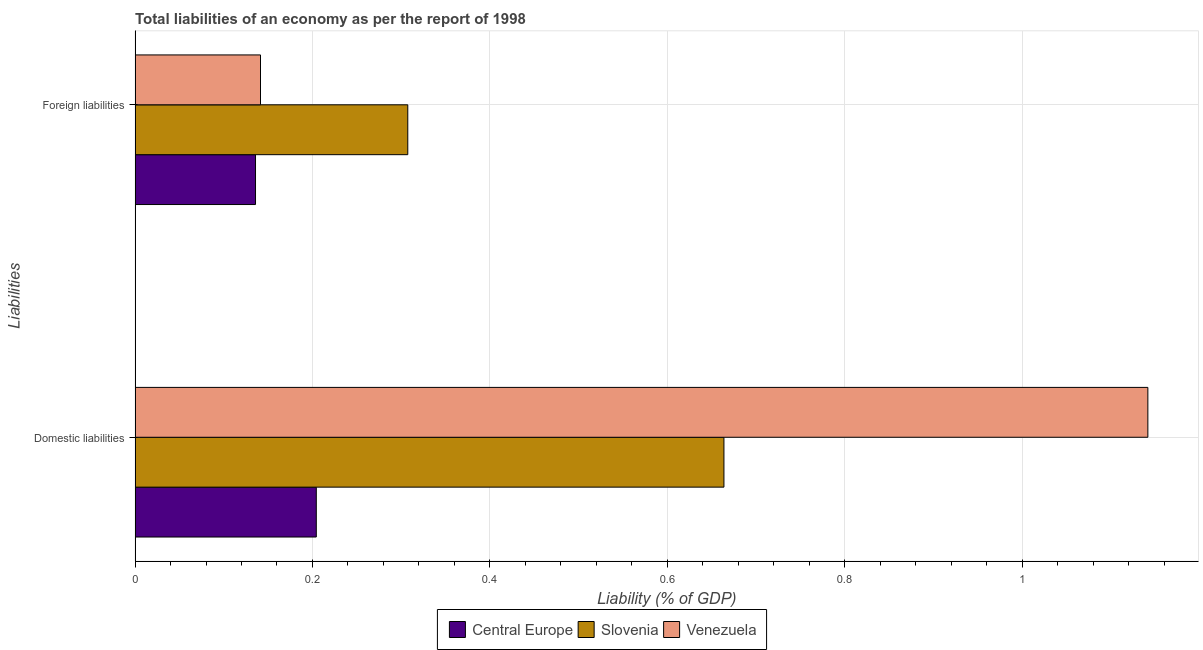How many groups of bars are there?
Give a very brief answer. 2. How many bars are there on the 1st tick from the bottom?
Give a very brief answer. 3. What is the label of the 1st group of bars from the top?
Make the answer very short. Foreign liabilities. What is the incurrence of foreign liabilities in Venezuela?
Your answer should be very brief. 0.14. Across all countries, what is the maximum incurrence of domestic liabilities?
Keep it short and to the point. 1.14. Across all countries, what is the minimum incurrence of foreign liabilities?
Provide a succinct answer. 0.14. In which country was the incurrence of domestic liabilities maximum?
Provide a short and direct response. Venezuela. In which country was the incurrence of domestic liabilities minimum?
Provide a succinct answer. Central Europe. What is the total incurrence of foreign liabilities in the graph?
Offer a very short reply. 0.58. What is the difference between the incurrence of foreign liabilities in Slovenia and that in Venezuela?
Your answer should be compact. 0.17. What is the difference between the incurrence of domestic liabilities in Venezuela and the incurrence of foreign liabilities in Slovenia?
Your answer should be very brief. 0.83. What is the average incurrence of foreign liabilities per country?
Offer a very short reply. 0.19. What is the difference between the incurrence of foreign liabilities and incurrence of domestic liabilities in Central Europe?
Your response must be concise. -0.07. In how many countries, is the incurrence of domestic liabilities greater than 0.36 %?
Make the answer very short. 2. What is the ratio of the incurrence of foreign liabilities in Central Europe to that in Slovenia?
Provide a short and direct response. 0.44. What does the 3rd bar from the top in Domestic liabilities represents?
Ensure brevity in your answer.  Central Europe. What does the 3rd bar from the bottom in Foreign liabilities represents?
Offer a terse response. Venezuela. Are the values on the major ticks of X-axis written in scientific E-notation?
Give a very brief answer. No. Does the graph contain any zero values?
Offer a terse response. No. How many legend labels are there?
Offer a terse response. 3. What is the title of the graph?
Provide a succinct answer. Total liabilities of an economy as per the report of 1998. What is the label or title of the X-axis?
Your answer should be very brief. Liability (% of GDP). What is the label or title of the Y-axis?
Provide a succinct answer. Liabilities. What is the Liability (% of GDP) in Central Europe in Domestic liabilities?
Give a very brief answer. 0.2. What is the Liability (% of GDP) in Slovenia in Domestic liabilities?
Your answer should be very brief. 0.66. What is the Liability (% of GDP) of Venezuela in Domestic liabilities?
Your answer should be compact. 1.14. What is the Liability (% of GDP) in Central Europe in Foreign liabilities?
Give a very brief answer. 0.14. What is the Liability (% of GDP) of Slovenia in Foreign liabilities?
Keep it short and to the point. 0.31. What is the Liability (% of GDP) in Venezuela in Foreign liabilities?
Your response must be concise. 0.14. Across all Liabilities, what is the maximum Liability (% of GDP) of Central Europe?
Provide a short and direct response. 0.2. Across all Liabilities, what is the maximum Liability (% of GDP) of Slovenia?
Provide a succinct answer. 0.66. Across all Liabilities, what is the maximum Liability (% of GDP) in Venezuela?
Make the answer very short. 1.14. Across all Liabilities, what is the minimum Liability (% of GDP) in Central Europe?
Give a very brief answer. 0.14. Across all Liabilities, what is the minimum Liability (% of GDP) in Slovenia?
Make the answer very short. 0.31. Across all Liabilities, what is the minimum Liability (% of GDP) of Venezuela?
Keep it short and to the point. 0.14. What is the total Liability (% of GDP) in Central Europe in the graph?
Offer a terse response. 0.34. What is the total Liability (% of GDP) of Slovenia in the graph?
Your answer should be very brief. 0.97. What is the total Liability (% of GDP) in Venezuela in the graph?
Your answer should be compact. 1.28. What is the difference between the Liability (% of GDP) of Central Europe in Domestic liabilities and that in Foreign liabilities?
Make the answer very short. 0.07. What is the difference between the Liability (% of GDP) in Slovenia in Domestic liabilities and that in Foreign liabilities?
Provide a succinct answer. 0.36. What is the difference between the Liability (% of GDP) in Central Europe in Domestic liabilities and the Liability (% of GDP) in Slovenia in Foreign liabilities?
Your answer should be very brief. -0.1. What is the difference between the Liability (% of GDP) of Central Europe in Domestic liabilities and the Liability (% of GDP) of Venezuela in Foreign liabilities?
Keep it short and to the point. 0.06. What is the difference between the Liability (% of GDP) in Slovenia in Domestic liabilities and the Liability (% of GDP) in Venezuela in Foreign liabilities?
Your response must be concise. 0.52. What is the average Liability (% of GDP) of Central Europe per Liabilities?
Provide a short and direct response. 0.17. What is the average Liability (% of GDP) of Slovenia per Liabilities?
Give a very brief answer. 0.49. What is the average Liability (% of GDP) in Venezuela per Liabilities?
Offer a terse response. 0.64. What is the difference between the Liability (% of GDP) of Central Europe and Liability (% of GDP) of Slovenia in Domestic liabilities?
Make the answer very short. -0.46. What is the difference between the Liability (% of GDP) of Central Europe and Liability (% of GDP) of Venezuela in Domestic liabilities?
Keep it short and to the point. -0.94. What is the difference between the Liability (% of GDP) in Slovenia and Liability (% of GDP) in Venezuela in Domestic liabilities?
Offer a very short reply. -0.48. What is the difference between the Liability (% of GDP) in Central Europe and Liability (% of GDP) in Slovenia in Foreign liabilities?
Keep it short and to the point. -0.17. What is the difference between the Liability (% of GDP) in Central Europe and Liability (% of GDP) in Venezuela in Foreign liabilities?
Your answer should be very brief. -0.01. What is the difference between the Liability (% of GDP) of Slovenia and Liability (% of GDP) of Venezuela in Foreign liabilities?
Your answer should be compact. 0.17. What is the ratio of the Liability (% of GDP) in Central Europe in Domestic liabilities to that in Foreign liabilities?
Your answer should be compact. 1.5. What is the ratio of the Liability (% of GDP) of Slovenia in Domestic liabilities to that in Foreign liabilities?
Offer a terse response. 2.16. What is the ratio of the Liability (% of GDP) in Venezuela in Domestic liabilities to that in Foreign liabilities?
Offer a terse response. 8.07. What is the difference between the highest and the second highest Liability (% of GDP) of Central Europe?
Your response must be concise. 0.07. What is the difference between the highest and the second highest Liability (% of GDP) of Slovenia?
Your answer should be compact. 0.36. What is the difference between the highest and the lowest Liability (% of GDP) in Central Europe?
Offer a terse response. 0.07. What is the difference between the highest and the lowest Liability (% of GDP) of Slovenia?
Provide a succinct answer. 0.36. 